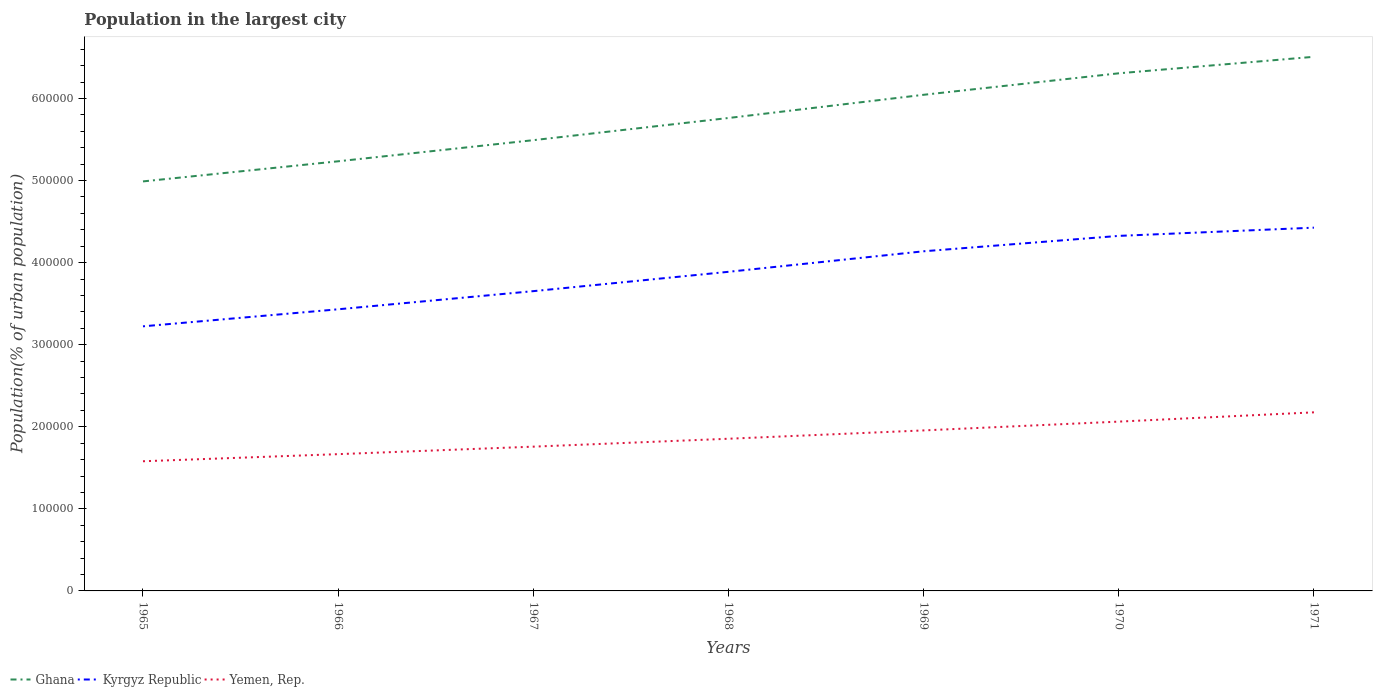Across all years, what is the maximum population in the largest city in Yemen, Rep.?
Give a very brief answer. 1.58e+05. In which year was the population in the largest city in Yemen, Rep. maximum?
Give a very brief answer. 1965. What is the total population in the largest city in Kyrgyz Republic in the graph?
Your response must be concise. -1.10e+05. What is the difference between the highest and the second highest population in the largest city in Kyrgyz Republic?
Your answer should be compact. 1.20e+05. What is the difference between the highest and the lowest population in the largest city in Kyrgyz Republic?
Give a very brief answer. 4. Is the population in the largest city in Yemen, Rep. strictly greater than the population in the largest city in Ghana over the years?
Offer a terse response. Yes. How many years are there in the graph?
Offer a very short reply. 7. What is the difference between two consecutive major ticks on the Y-axis?
Provide a succinct answer. 1.00e+05. Are the values on the major ticks of Y-axis written in scientific E-notation?
Provide a succinct answer. No. Does the graph contain grids?
Offer a very short reply. No. How are the legend labels stacked?
Offer a very short reply. Horizontal. What is the title of the graph?
Make the answer very short. Population in the largest city. Does "Qatar" appear as one of the legend labels in the graph?
Your response must be concise. No. What is the label or title of the Y-axis?
Offer a very short reply. Population(% of urban population). What is the Population(% of urban population) of Ghana in 1965?
Your answer should be very brief. 4.99e+05. What is the Population(% of urban population) of Kyrgyz Republic in 1965?
Make the answer very short. 3.22e+05. What is the Population(% of urban population) of Yemen, Rep. in 1965?
Your answer should be very brief. 1.58e+05. What is the Population(% of urban population) of Ghana in 1966?
Keep it short and to the point. 5.23e+05. What is the Population(% of urban population) in Kyrgyz Republic in 1966?
Provide a short and direct response. 3.43e+05. What is the Population(% of urban population) in Yemen, Rep. in 1966?
Your answer should be very brief. 1.67e+05. What is the Population(% of urban population) of Ghana in 1967?
Your response must be concise. 5.49e+05. What is the Population(% of urban population) in Kyrgyz Republic in 1967?
Your response must be concise. 3.65e+05. What is the Population(% of urban population) of Yemen, Rep. in 1967?
Offer a terse response. 1.76e+05. What is the Population(% of urban population) in Ghana in 1968?
Provide a succinct answer. 5.76e+05. What is the Population(% of urban population) in Kyrgyz Republic in 1968?
Provide a succinct answer. 3.89e+05. What is the Population(% of urban population) of Yemen, Rep. in 1968?
Offer a very short reply. 1.85e+05. What is the Population(% of urban population) of Ghana in 1969?
Provide a short and direct response. 6.04e+05. What is the Population(% of urban population) of Kyrgyz Republic in 1969?
Offer a terse response. 4.14e+05. What is the Population(% of urban population) of Yemen, Rep. in 1969?
Offer a very short reply. 1.96e+05. What is the Population(% of urban population) of Ghana in 1970?
Ensure brevity in your answer.  6.31e+05. What is the Population(% of urban population) of Kyrgyz Republic in 1970?
Provide a succinct answer. 4.33e+05. What is the Population(% of urban population) of Yemen, Rep. in 1970?
Your answer should be compact. 2.06e+05. What is the Population(% of urban population) in Ghana in 1971?
Your response must be concise. 6.51e+05. What is the Population(% of urban population) in Kyrgyz Republic in 1971?
Your answer should be compact. 4.43e+05. What is the Population(% of urban population) of Yemen, Rep. in 1971?
Provide a succinct answer. 2.18e+05. Across all years, what is the maximum Population(% of urban population) in Ghana?
Your answer should be very brief. 6.51e+05. Across all years, what is the maximum Population(% of urban population) of Kyrgyz Republic?
Provide a succinct answer. 4.43e+05. Across all years, what is the maximum Population(% of urban population) of Yemen, Rep.?
Make the answer very short. 2.18e+05. Across all years, what is the minimum Population(% of urban population) in Ghana?
Make the answer very short. 4.99e+05. Across all years, what is the minimum Population(% of urban population) in Kyrgyz Republic?
Make the answer very short. 3.22e+05. Across all years, what is the minimum Population(% of urban population) in Yemen, Rep.?
Provide a succinct answer. 1.58e+05. What is the total Population(% of urban population) in Ghana in the graph?
Keep it short and to the point. 4.03e+06. What is the total Population(% of urban population) of Kyrgyz Republic in the graph?
Your answer should be compact. 2.71e+06. What is the total Population(% of urban population) of Yemen, Rep. in the graph?
Your answer should be very brief. 1.31e+06. What is the difference between the Population(% of urban population) of Ghana in 1965 and that in 1966?
Your answer should be very brief. -2.45e+04. What is the difference between the Population(% of urban population) of Kyrgyz Republic in 1965 and that in 1966?
Make the answer very short. -2.08e+04. What is the difference between the Population(% of urban population) in Yemen, Rep. in 1965 and that in 1966?
Offer a very short reply. -8658. What is the difference between the Population(% of urban population) in Ghana in 1965 and that in 1967?
Provide a succinct answer. -5.02e+04. What is the difference between the Population(% of urban population) in Kyrgyz Republic in 1965 and that in 1967?
Make the answer very short. -4.29e+04. What is the difference between the Population(% of urban population) of Yemen, Rep. in 1965 and that in 1967?
Keep it short and to the point. -1.78e+04. What is the difference between the Population(% of urban population) in Ghana in 1965 and that in 1968?
Your response must be concise. -7.73e+04. What is the difference between the Population(% of urban population) in Kyrgyz Republic in 1965 and that in 1968?
Keep it short and to the point. -6.64e+04. What is the difference between the Population(% of urban population) in Yemen, Rep. in 1965 and that in 1968?
Provide a succinct answer. -2.74e+04. What is the difference between the Population(% of urban population) in Ghana in 1965 and that in 1969?
Ensure brevity in your answer.  -1.06e+05. What is the difference between the Population(% of urban population) of Kyrgyz Republic in 1965 and that in 1969?
Offer a terse response. -9.14e+04. What is the difference between the Population(% of urban population) in Yemen, Rep. in 1965 and that in 1969?
Make the answer very short. -3.76e+04. What is the difference between the Population(% of urban population) in Ghana in 1965 and that in 1970?
Ensure brevity in your answer.  -1.32e+05. What is the difference between the Population(% of urban population) of Kyrgyz Republic in 1965 and that in 1970?
Your answer should be very brief. -1.10e+05. What is the difference between the Population(% of urban population) of Yemen, Rep. in 1965 and that in 1970?
Keep it short and to the point. -4.83e+04. What is the difference between the Population(% of urban population) of Ghana in 1965 and that in 1971?
Provide a short and direct response. -1.52e+05. What is the difference between the Population(% of urban population) in Kyrgyz Republic in 1965 and that in 1971?
Offer a very short reply. -1.20e+05. What is the difference between the Population(% of urban population) of Yemen, Rep. in 1965 and that in 1971?
Ensure brevity in your answer.  -5.96e+04. What is the difference between the Population(% of urban population) in Ghana in 1966 and that in 1967?
Your answer should be very brief. -2.57e+04. What is the difference between the Population(% of urban population) of Kyrgyz Republic in 1966 and that in 1967?
Make the answer very short. -2.21e+04. What is the difference between the Population(% of urban population) in Yemen, Rep. in 1966 and that in 1967?
Provide a short and direct response. -9132. What is the difference between the Population(% of urban population) of Ghana in 1966 and that in 1968?
Your answer should be very brief. -5.27e+04. What is the difference between the Population(% of urban population) in Kyrgyz Republic in 1966 and that in 1968?
Your response must be concise. -4.57e+04. What is the difference between the Population(% of urban population) in Yemen, Rep. in 1966 and that in 1968?
Keep it short and to the point. -1.88e+04. What is the difference between the Population(% of urban population) of Ghana in 1966 and that in 1969?
Offer a very short reply. -8.10e+04. What is the difference between the Population(% of urban population) of Kyrgyz Republic in 1966 and that in 1969?
Your answer should be very brief. -7.07e+04. What is the difference between the Population(% of urban population) in Yemen, Rep. in 1966 and that in 1969?
Your response must be concise. -2.89e+04. What is the difference between the Population(% of urban population) in Ghana in 1966 and that in 1970?
Provide a succinct answer. -1.07e+05. What is the difference between the Population(% of urban population) in Kyrgyz Republic in 1966 and that in 1970?
Your answer should be compact. -8.94e+04. What is the difference between the Population(% of urban population) in Yemen, Rep. in 1966 and that in 1970?
Make the answer very short. -3.96e+04. What is the difference between the Population(% of urban population) of Ghana in 1966 and that in 1971?
Make the answer very short. -1.27e+05. What is the difference between the Population(% of urban population) in Kyrgyz Republic in 1966 and that in 1971?
Give a very brief answer. -9.95e+04. What is the difference between the Population(% of urban population) of Yemen, Rep. in 1966 and that in 1971?
Your answer should be very brief. -5.09e+04. What is the difference between the Population(% of urban population) in Ghana in 1967 and that in 1968?
Offer a terse response. -2.70e+04. What is the difference between the Population(% of urban population) of Kyrgyz Republic in 1967 and that in 1968?
Ensure brevity in your answer.  -2.36e+04. What is the difference between the Population(% of urban population) of Yemen, Rep. in 1967 and that in 1968?
Your answer should be compact. -9647. What is the difference between the Population(% of urban population) in Ghana in 1967 and that in 1969?
Your response must be concise. -5.53e+04. What is the difference between the Population(% of urban population) in Kyrgyz Republic in 1967 and that in 1969?
Give a very brief answer. -4.86e+04. What is the difference between the Population(% of urban population) in Yemen, Rep. in 1967 and that in 1969?
Your answer should be compact. -1.98e+04. What is the difference between the Population(% of urban population) in Ghana in 1967 and that in 1970?
Your answer should be very brief. -8.15e+04. What is the difference between the Population(% of urban population) in Kyrgyz Republic in 1967 and that in 1970?
Your answer should be compact. -6.73e+04. What is the difference between the Population(% of urban population) in Yemen, Rep. in 1967 and that in 1970?
Provide a short and direct response. -3.05e+04. What is the difference between the Population(% of urban population) in Ghana in 1967 and that in 1971?
Your answer should be very brief. -1.02e+05. What is the difference between the Population(% of urban population) of Kyrgyz Republic in 1967 and that in 1971?
Offer a very short reply. -7.74e+04. What is the difference between the Population(% of urban population) in Yemen, Rep. in 1967 and that in 1971?
Make the answer very short. -4.18e+04. What is the difference between the Population(% of urban population) of Ghana in 1968 and that in 1969?
Your answer should be compact. -2.83e+04. What is the difference between the Population(% of urban population) in Kyrgyz Republic in 1968 and that in 1969?
Your answer should be compact. -2.50e+04. What is the difference between the Population(% of urban population) of Yemen, Rep. in 1968 and that in 1969?
Offer a terse response. -1.01e+04. What is the difference between the Population(% of urban population) of Ghana in 1968 and that in 1970?
Offer a very short reply. -5.45e+04. What is the difference between the Population(% of urban population) in Kyrgyz Republic in 1968 and that in 1970?
Give a very brief answer. -4.38e+04. What is the difference between the Population(% of urban population) in Yemen, Rep. in 1968 and that in 1970?
Give a very brief answer. -2.09e+04. What is the difference between the Population(% of urban population) in Ghana in 1968 and that in 1971?
Provide a short and direct response. -7.46e+04. What is the difference between the Population(% of urban population) in Kyrgyz Republic in 1968 and that in 1971?
Keep it short and to the point. -5.38e+04. What is the difference between the Population(% of urban population) in Yemen, Rep. in 1968 and that in 1971?
Make the answer very short. -3.22e+04. What is the difference between the Population(% of urban population) in Ghana in 1969 and that in 1970?
Your response must be concise. -2.62e+04. What is the difference between the Population(% of urban population) in Kyrgyz Republic in 1969 and that in 1970?
Offer a very short reply. -1.88e+04. What is the difference between the Population(% of urban population) in Yemen, Rep. in 1969 and that in 1970?
Give a very brief answer. -1.07e+04. What is the difference between the Population(% of urban population) of Ghana in 1969 and that in 1971?
Provide a succinct answer. -4.63e+04. What is the difference between the Population(% of urban population) of Kyrgyz Republic in 1969 and that in 1971?
Your response must be concise. -2.88e+04. What is the difference between the Population(% of urban population) in Yemen, Rep. in 1969 and that in 1971?
Provide a succinct answer. -2.20e+04. What is the difference between the Population(% of urban population) in Ghana in 1970 and that in 1971?
Give a very brief answer. -2.01e+04. What is the difference between the Population(% of urban population) in Kyrgyz Republic in 1970 and that in 1971?
Offer a terse response. -1.00e+04. What is the difference between the Population(% of urban population) in Yemen, Rep. in 1970 and that in 1971?
Make the answer very short. -1.13e+04. What is the difference between the Population(% of urban population) of Ghana in 1965 and the Population(% of urban population) of Kyrgyz Republic in 1966?
Offer a very short reply. 1.56e+05. What is the difference between the Population(% of urban population) of Ghana in 1965 and the Population(% of urban population) of Yemen, Rep. in 1966?
Keep it short and to the point. 3.32e+05. What is the difference between the Population(% of urban population) of Kyrgyz Republic in 1965 and the Population(% of urban population) of Yemen, Rep. in 1966?
Offer a very short reply. 1.56e+05. What is the difference between the Population(% of urban population) of Ghana in 1965 and the Population(% of urban population) of Kyrgyz Republic in 1967?
Provide a short and direct response. 1.34e+05. What is the difference between the Population(% of urban population) of Ghana in 1965 and the Population(% of urban population) of Yemen, Rep. in 1967?
Your response must be concise. 3.23e+05. What is the difference between the Population(% of urban population) in Kyrgyz Republic in 1965 and the Population(% of urban population) in Yemen, Rep. in 1967?
Your response must be concise. 1.47e+05. What is the difference between the Population(% of urban population) in Ghana in 1965 and the Population(% of urban population) in Kyrgyz Republic in 1968?
Provide a short and direct response. 1.10e+05. What is the difference between the Population(% of urban population) of Ghana in 1965 and the Population(% of urban population) of Yemen, Rep. in 1968?
Offer a very short reply. 3.14e+05. What is the difference between the Population(% of urban population) of Kyrgyz Republic in 1965 and the Population(% of urban population) of Yemen, Rep. in 1968?
Provide a short and direct response. 1.37e+05. What is the difference between the Population(% of urban population) in Ghana in 1965 and the Population(% of urban population) in Kyrgyz Republic in 1969?
Your response must be concise. 8.51e+04. What is the difference between the Population(% of urban population) of Ghana in 1965 and the Population(% of urban population) of Yemen, Rep. in 1969?
Your answer should be very brief. 3.03e+05. What is the difference between the Population(% of urban population) of Kyrgyz Republic in 1965 and the Population(% of urban population) of Yemen, Rep. in 1969?
Your answer should be very brief. 1.27e+05. What is the difference between the Population(% of urban population) of Ghana in 1965 and the Population(% of urban population) of Kyrgyz Republic in 1970?
Make the answer very short. 6.64e+04. What is the difference between the Population(% of urban population) in Ghana in 1965 and the Population(% of urban population) in Yemen, Rep. in 1970?
Provide a short and direct response. 2.93e+05. What is the difference between the Population(% of urban population) of Kyrgyz Republic in 1965 and the Population(% of urban population) of Yemen, Rep. in 1970?
Make the answer very short. 1.16e+05. What is the difference between the Population(% of urban population) in Ghana in 1965 and the Population(% of urban population) in Kyrgyz Republic in 1971?
Your response must be concise. 5.64e+04. What is the difference between the Population(% of urban population) in Ghana in 1965 and the Population(% of urban population) in Yemen, Rep. in 1971?
Ensure brevity in your answer.  2.81e+05. What is the difference between the Population(% of urban population) in Kyrgyz Republic in 1965 and the Population(% of urban population) in Yemen, Rep. in 1971?
Offer a terse response. 1.05e+05. What is the difference between the Population(% of urban population) in Ghana in 1966 and the Population(% of urban population) in Kyrgyz Republic in 1967?
Offer a very short reply. 1.58e+05. What is the difference between the Population(% of urban population) of Ghana in 1966 and the Population(% of urban population) of Yemen, Rep. in 1967?
Offer a very short reply. 3.48e+05. What is the difference between the Population(% of urban population) of Kyrgyz Republic in 1966 and the Population(% of urban population) of Yemen, Rep. in 1967?
Provide a succinct answer. 1.67e+05. What is the difference between the Population(% of urban population) of Ghana in 1966 and the Population(% of urban population) of Kyrgyz Republic in 1968?
Offer a very short reply. 1.35e+05. What is the difference between the Population(% of urban population) of Ghana in 1966 and the Population(% of urban population) of Yemen, Rep. in 1968?
Your answer should be very brief. 3.38e+05. What is the difference between the Population(% of urban population) in Kyrgyz Republic in 1966 and the Population(% of urban population) in Yemen, Rep. in 1968?
Your response must be concise. 1.58e+05. What is the difference between the Population(% of urban population) of Ghana in 1966 and the Population(% of urban population) of Kyrgyz Republic in 1969?
Provide a short and direct response. 1.10e+05. What is the difference between the Population(% of urban population) in Ghana in 1966 and the Population(% of urban population) in Yemen, Rep. in 1969?
Make the answer very short. 3.28e+05. What is the difference between the Population(% of urban population) in Kyrgyz Republic in 1966 and the Population(% of urban population) in Yemen, Rep. in 1969?
Keep it short and to the point. 1.48e+05. What is the difference between the Population(% of urban population) in Ghana in 1966 and the Population(% of urban population) in Kyrgyz Republic in 1970?
Make the answer very short. 9.09e+04. What is the difference between the Population(% of urban population) of Ghana in 1966 and the Population(% of urban population) of Yemen, Rep. in 1970?
Provide a succinct answer. 3.17e+05. What is the difference between the Population(% of urban population) of Kyrgyz Republic in 1966 and the Population(% of urban population) of Yemen, Rep. in 1970?
Offer a terse response. 1.37e+05. What is the difference between the Population(% of urban population) of Ghana in 1966 and the Population(% of urban population) of Kyrgyz Republic in 1971?
Your answer should be compact. 8.09e+04. What is the difference between the Population(% of urban population) in Ghana in 1966 and the Population(% of urban population) in Yemen, Rep. in 1971?
Your response must be concise. 3.06e+05. What is the difference between the Population(% of urban population) in Kyrgyz Republic in 1966 and the Population(% of urban population) in Yemen, Rep. in 1971?
Your response must be concise. 1.26e+05. What is the difference between the Population(% of urban population) in Ghana in 1967 and the Population(% of urban population) in Kyrgyz Republic in 1968?
Your response must be concise. 1.60e+05. What is the difference between the Population(% of urban population) in Ghana in 1967 and the Population(% of urban population) in Yemen, Rep. in 1968?
Offer a terse response. 3.64e+05. What is the difference between the Population(% of urban population) of Kyrgyz Republic in 1967 and the Population(% of urban population) of Yemen, Rep. in 1968?
Provide a short and direct response. 1.80e+05. What is the difference between the Population(% of urban population) in Ghana in 1967 and the Population(% of urban population) in Kyrgyz Republic in 1969?
Make the answer very short. 1.35e+05. What is the difference between the Population(% of urban population) in Ghana in 1967 and the Population(% of urban population) in Yemen, Rep. in 1969?
Your answer should be very brief. 3.54e+05. What is the difference between the Population(% of urban population) of Kyrgyz Republic in 1967 and the Population(% of urban population) of Yemen, Rep. in 1969?
Your answer should be very brief. 1.70e+05. What is the difference between the Population(% of urban population) of Ghana in 1967 and the Population(% of urban population) of Kyrgyz Republic in 1970?
Make the answer very short. 1.17e+05. What is the difference between the Population(% of urban population) of Ghana in 1967 and the Population(% of urban population) of Yemen, Rep. in 1970?
Your answer should be compact. 3.43e+05. What is the difference between the Population(% of urban population) in Kyrgyz Republic in 1967 and the Population(% of urban population) in Yemen, Rep. in 1970?
Offer a very short reply. 1.59e+05. What is the difference between the Population(% of urban population) of Ghana in 1967 and the Population(% of urban population) of Kyrgyz Republic in 1971?
Your answer should be compact. 1.07e+05. What is the difference between the Population(% of urban population) in Ghana in 1967 and the Population(% of urban population) in Yemen, Rep. in 1971?
Your answer should be compact. 3.32e+05. What is the difference between the Population(% of urban population) in Kyrgyz Republic in 1967 and the Population(% of urban population) in Yemen, Rep. in 1971?
Your answer should be compact. 1.48e+05. What is the difference between the Population(% of urban population) in Ghana in 1968 and the Population(% of urban population) in Kyrgyz Republic in 1969?
Ensure brevity in your answer.  1.62e+05. What is the difference between the Population(% of urban population) in Ghana in 1968 and the Population(% of urban population) in Yemen, Rep. in 1969?
Provide a succinct answer. 3.81e+05. What is the difference between the Population(% of urban population) of Kyrgyz Republic in 1968 and the Population(% of urban population) of Yemen, Rep. in 1969?
Make the answer very short. 1.93e+05. What is the difference between the Population(% of urban population) in Ghana in 1968 and the Population(% of urban population) in Kyrgyz Republic in 1970?
Provide a short and direct response. 1.44e+05. What is the difference between the Population(% of urban population) of Ghana in 1968 and the Population(% of urban population) of Yemen, Rep. in 1970?
Make the answer very short. 3.70e+05. What is the difference between the Population(% of urban population) of Kyrgyz Republic in 1968 and the Population(% of urban population) of Yemen, Rep. in 1970?
Provide a succinct answer. 1.83e+05. What is the difference between the Population(% of urban population) of Ghana in 1968 and the Population(% of urban population) of Kyrgyz Republic in 1971?
Your answer should be compact. 1.34e+05. What is the difference between the Population(% of urban population) of Ghana in 1968 and the Population(% of urban population) of Yemen, Rep. in 1971?
Make the answer very short. 3.59e+05. What is the difference between the Population(% of urban population) of Kyrgyz Republic in 1968 and the Population(% of urban population) of Yemen, Rep. in 1971?
Ensure brevity in your answer.  1.71e+05. What is the difference between the Population(% of urban population) in Ghana in 1969 and the Population(% of urban population) in Kyrgyz Republic in 1970?
Provide a short and direct response. 1.72e+05. What is the difference between the Population(% of urban population) in Ghana in 1969 and the Population(% of urban population) in Yemen, Rep. in 1970?
Offer a very short reply. 3.98e+05. What is the difference between the Population(% of urban population) of Kyrgyz Republic in 1969 and the Population(% of urban population) of Yemen, Rep. in 1970?
Offer a terse response. 2.08e+05. What is the difference between the Population(% of urban population) in Ghana in 1969 and the Population(% of urban population) in Kyrgyz Republic in 1971?
Provide a short and direct response. 1.62e+05. What is the difference between the Population(% of urban population) in Ghana in 1969 and the Population(% of urban population) in Yemen, Rep. in 1971?
Ensure brevity in your answer.  3.87e+05. What is the difference between the Population(% of urban population) of Kyrgyz Republic in 1969 and the Population(% of urban population) of Yemen, Rep. in 1971?
Your answer should be compact. 1.96e+05. What is the difference between the Population(% of urban population) in Ghana in 1970 and the Population(% of urban population) in Kyrgyz Republic in 1971?
Make the answer very short. 1.88e+05. What is the difference between the Population(% of urban population) of Ghana in 1970 and the Population(% of urban population) of Yemen, Rep. in 1971?
Make the answer very short. 4.13e+05. What is the difference between the Population(% of urban population) in Kyrgyz Republic in 1970 and the Population(% of urban population) in Yemen, Rep. in 1971?
Give a very brief answer. 2.15e+05. What is the average Population(% of urban population) in Ghana per year?
Your answer should be very brief. 5.76e+05. What is the average Population(% of urban population) in Kyrgyz Republic per year?
Provide a succinct answer. 3.87e+05. What is the average Population(% of urban population) of Yemen, Rep. per year?
Provide a succinct answer. 1.86e+05. In the year 1965, what is the difference between the Population(% of urban population) of Ghana and Population(% of urban population) of Kyrgyz Republic?
Offer a very short reply. 1.77e+05. In the year 1965, what is the difference between the Population(% of urban population) in Ghana and Population(% of urban population) in Yemen, Rep.?
Your response must be concise. 3.41e+05. In the year 1965, what is the difference between the Population(% of urban population) in Kyrgyz Republic and Population(% of urban population) in Yemen, Rep.?
Offer a very short reply. 1.64e+05. In the year 1966, what is the difference between the Population(% of urban population) of Ghana and Population(% of urban population) of Kyrgyz Republic?
Your answer should be very brief. 1.80e+05. In the year 1966, what is the difference between the Population(% of urban population) of Ghana and Population(% of urban population) of Yemen, Rep.?
Your response must be concise. 3.57e+05. In the year 1966, what is the difference between the Population(% of urban population) of Kyrgyz Republic and Population(% of urban population) of Yemen, Rep.?
Provide a short and direct response. 1.76e+05. In the year 1967, what is the difference between the Population(% of urban population) in Ghana and Population(% of urban population) in Kyrgyz Republic?
Offer a terse response. 1.84e+05. In the year 1967, what is the difference between the Population(% of urban population) of Ghana and Population(% of urban population) of Yemen, Rep.?
Keep it short and to the point. 3.73e+05. In the year 1967, what is the difference between the Population(% of urban population) of Kyrgyz Republic and Population(% of urban population) of Yemen, Rep.?
Ensure brevity in your answer.  1.89e+05. In the year 1968, what is the difference between the Population(% of urban population) in Ghana and Population(% of urban population) in Kyrgyz Republic?
Offer a very short reply. 1.87e+05. In the year 1968, what is the difference between the Population(% of urban population) in Ghana and Population(% of urban population) in Yemen, Rep.?
Your answer should be very brief. 3.91e+05. In the year 1968, what is the difference between the Population(% of urban population) of Kyrgyz Republic and Population(% of urban population) of Yemen, Rep.?
Ensure brevity in your answer.  2.03e+05. In the year 1969, what is the difference between the Population(% of urban population) in Ghana and Population(% of urban population) in Kyrgyz Republic?
Provide a short and direct response. 1.91e+05. In the year 1969, what is the difference between the Population(% of urban population) of Ghana and Population(% of urban population) of Yemen, Rep.?
Provide a succinct answer. 4.09e+05. In the year 1969, what is the difference between the Population(% of urban population) of Kyrgyz Republic and Population(% of urban population) of Yemen, Rep.?
Make the answer very short. 2.18e+05. In the year 1970, what is the difference between the Population(% of urban population) in Ghana and Population(% of urban population) in Kyrgyz Republic?
Your response must be concise. 1.98e+05. In the year 1970, what is the difference between the Population(% of urban population) of Ghana and Population(% of urban population) of Yemen, Rep.?
Offer a terse response. 4.24e+05. In the year 1970, what is the difference between the Population(% of urban population) of Kyrgyz Republic and Population(% of urban population) of Yemen, Rep.?
Make the answer very short. 2.26e+05. In the year 1971, what is the difference between the Population(% of urban population) in Ghana and Population(% of urban population) in Kyrgyz Republic?
Keep it short and to the point. 2.08e+05. In the year 1971, what is the difference between the Population(% of urban population) in Ghana and Population(% of urban population) in Yemen, Rep.?
Your response must be concise. 4.33e+05. In the year 1971, what is the difference between the Population(% of urban population) in Kyrgyz Republic and Population(% of urban population) in Yemen, Rep.?
Provide a short and direct response. 2.25e+05. What is the ratio of the Population(% of urban population) of Ghana in 1965 to that in 1966?
Provide a short and direct response. 0.95. What is the ratio of the Population(% of urban population) of Kyrgyz Republic in 1965 to that in 1966?
Offer a terse response. 0.94. What is the ratio of the Population(% of urban population) of Yemen, Rep. in 1965 to that in 1966?
Offer a terse response. 0.95. What is the ratio of the Population(% of urban population) in Ghana in 1965 to that in 1967?
Offer a very short reply. 0.91. What is the ratio of the Population(% of urban population) of Kyrgyz Republic in 1965 to that in 1967?
Ensure brevity in your answer.  0.88. What is the ratio of the Population(% of urban population) of Yemen, Rep. in 1965 to that in 1967?
Your answer should be compact. 0.9. What is the ratio of the Population(% of urban population) in Ghana in 1965 to that in 1968?
Offer a very short reply. 0.87. What is the ratio of the Population(% of urban population) in Kyrgyz Republic in 1965 to that in 1968?
Your answer should be very brief. 0.83. What is the ratio of the Population(% of urban population) in Yemen, Rep. in 1965 to that in 1968?
Offer a very short reply. 0.85. What is the ratio of the Population(% of urban population) in Ghana in 1965 to that in 1969?
Keep it short and to the point. 0.83. What is the ratio of the Population(% of urban population) in Kyrgyz Republic in 1965 to that in 1969?
Ensure brevity in your answer.  0.78. What is the ratio of the Population(% of urban population) in Yemen, Rep. in 1965 to that in 1969?
Make the answer very short. 0.81. What is the ratio of the Population(% of urban population) in Ghana in 1965 to that in 1970?
Provide a succinct answer. 0.79. What is the ratio of the Population(% of urban population) of Kyrgyz Republic in 1965 to that in 1970?
Give a very brief answer. 0.75. What is the ratio of the Population(% of urban population) in Yemen, Rep. in 1965 to that in 1970?
Offer a very short reply. 0.77. What is the ratio of the Population(% of urban population) in Ghana in 1965 to that in 1971?
Give a very brief answer. 0.77. What is the ratio of the Population(% of urban population) in Kyrgyz Republic in 1965 to that in 1971?
Keep it short and to the point. 0.73. What is the ratio of the Population(% of urban population) in Yemen, Rep. in 1965 to that in 1971?
Ensure brevity in your answer.  0.73. What is the ratio of the Population(% of urban population) of Ghana in 1966 to that in 1967?
Offer a very short reply. 0.95. What is the ratio of the Population(% of urban population) in Kyrgyz Republic in 1966 to that in 1967?
Keep it short and to the point. 0.94. What is the ratio of the Population(% of urban population) of Yemen, Rep. in 1966 to that in 1967?
Offer a very short reply. 0.95. What is the ratio of the Population(% of urban population) in Ghana in 1966 to that in 1968?
Give a very brief answer. 0.91. What is the ratio of the Population(% of urban population) in Kyrgyz Republic in 1966 to that in 1968?
Provide a succinct answer. 0.88. What is the ratio of the Population(% of urban population) of Yemen, Rep. in 1966 to that in 1968?
Your answer should be compact. 0.9. What is the ratio of the Population(% of urban population) in Ghana in 1966 to that in 1969?
Keep it short and to the point. 0.87. What is the ratio of the Population(% of urban population) in Kyrgyz Republic in 1966 to that in 1969?
Your response must be concise. 0.83. What is the ratio of the Population(% of urban population) of Yemen, Rep. in 1966 to that in 1969?
Provide a short and direct response. 0.85. What is the ratio of the Population(% of urban population) in Ghana in 1966 to that in 1970?
Provide a short and direct response. 0.83. What is the ratio of the Population(% of urban population) of Kyrgyz Republic in 1966 to that in 1970?
Keep it short and to the point. 0.79. What is the ratio of the Population(% of urban population) of Yemen, Rep. in 1966 to that in 1970?
Ensure brevity in your answer.  0.81. What is the ratio of the Population(% of urban population) in Ghana in 1966 to that in 1971?
Offer a very short reply. 0.8. What is the ratio of the Population(% of urban population) in Kyrgyz Republic in 1966 to that in 1971?
Ensure brevity in your answer.  0.78. What is the ratio of the Population(% of urban population) of Yemen, Rep. in 1966 to that in 1971?
Provide a short and direct response. 0.77. What is the ratio of the Population(% of urban population) in Ghana in 1967 to that in 1968?
Provide a succinct answer. 0.95. What is the ratio of the Population(% of urban population) of Kyrgyz Republic in 1967 to that in 1968?
Your answer should be compact. 0.94. What is the ratio of the Population(% of urban population) in Yemen, Rep. in 1967 to that in 1968?
Offer a terse response. 0.95. What is the ratio of the Population(% of urban population) of Ghana in 1967 to that in 1969?
Your response must be concise. 0.91. What is the ratio of the Population(% of urban population) in Kyrgyz Republic in 1967 to that in 1969?
Your answer should be compact. 0.88. What is the ratio of the Population(% of urban population) in Yemen, Rep. in 1967 to that in 1969?
Offer a terse response. 0.9. What is the ratio of the Population(% of urban population) of Ghana in 1967 to that in 1970?
Keep it short and to the point. 0.87. What is the ratio of the Population(% of urban population) in Kyrgyz Republic in 1967 to that in 1970?
Offer a very short reply. 0.84. What is the ratio of the Population(% of urban population) in Yemen, Rep. in 1967 to that in 1970?
Give a very brief answer. 0.85. What is the ratio of the Population(% of urban population) of Ghana in 1967 to that in 1971?
Provide a short and direct response. 0.84. What is the ratio of the Population(% of urban population) in Kyrgyz Republic in 1967 to that in 1971?
Provide a succinct answer. 0.83. What is the ratio of the Population(% of urban population) in Yemen, Rep. in 1967 to that in 1971?
Give a very brief answer. 0.81. What is the ratio of the Population(% of urban population) of Ghana in 1968 to that in 1969?
Your answer should be very brief. 0.95. What is the ratio of the Population(% of urban population) in Kyrgyz Republic in 1968 to that in 1969?
Keep it short and to the point. 0.94. What is the ratio of the Population(% of urban population) of Yemen, Rep. in 1968 to that in 1969?
Your answer should be very brief. 0.95. What is the ratio of the Population(% of urban population) in Ghana in 1968 to that in 1970?
Your response must be concise. 0.91. What is the ratio of the Population(% of urban population) of Kyrgyz Republic in 1968 to that in 1970?
Your response must be concise. 0.9. What is the ratio of the Population(% of urban population) in Yemen, Rep. in 1968 to that in 1970?
Your answer should be very brief. 0.9. What is the ratio of the Population(% of urban population) of Ghana in 1968 to that in 1971?
Give a very brief answer. 0.89. What is the ratio of the Population(% of urban population) of Kyrgyz Republic in 1968 to that in 1971?
Offer a very short reply. 0.88. What is the ratio of the Population(% of urban population) in Yemen, Rep. in 1968 to that in 1971?
Offer a terse response. 0.85. What is the ratio of the Population(% of urban population) of Ghana in 1969 to that in 1970?
Provide a short and direct response. 0.96. What is the ratio of the Population(% of urban population) of Kyrgyz Republic in 1969 to that in 1970?
Give a very brief answer. 0.96. What is the ratio of the Population(% of urban population) of Yemen, Rep. in 1969 to that in 1970?
Ensure brevity in your answer.  0.95. What is the ratio of the Population(% of urban population) in Ghana in 1969 to that in 1971?
Keep it short and to the point. 0.93. What is the ratio of the Population(% of urban population) in Kyrgyz Republic in 1969 to that in 1971?
Provide a succinct answer. 0.94. What is the ratio of the Population(% of urban population) in Yemen, Rep. in 1969 to that in 1971?
Ensure brevity in your answer.  0.9. What is the ratio of the Population(% of urban population) in Ghana in 1970 to that in 1971?
Offer a terse response. 0.97. What is the ratio of the Population(% of urban population) in Kyrgyz Republic in 1970 to that in 1971?
Offer a very short reply. 0.98. What is the ratio of the Population(% of urban population) in Yemen, Rep. in 1970 to that in 1971?
Your answer should be compact. 0.95. What is the difference between the highest and the second highest Population(% of urban population) in Ghana?
Ensure brevity in your answer.  2.01e+04. What is the difference between the highest and the second highest Population(% of urban population) of Kyrgyz Republic?
Offer a terse response. 1.00e+04. What is the difference between the highest and the second highest Population(% of urban population) of Yemen, Rep.?
Give a very brief answer. 1.13e+04. What is the difference between the highest and the lowest Population(% of urban population) of Ghana?
Your response must be concise. 1.52e+05. What is the difference between the highest and the lowest Population(% of urban population) in Kyrgyz Republic?
Give a very brief answer. 1.20e+05. What is the difference between the highest and the lowest Population(% of urban population) of Yemen, Rep.?
Your response must be concise. 5.96e+04. 